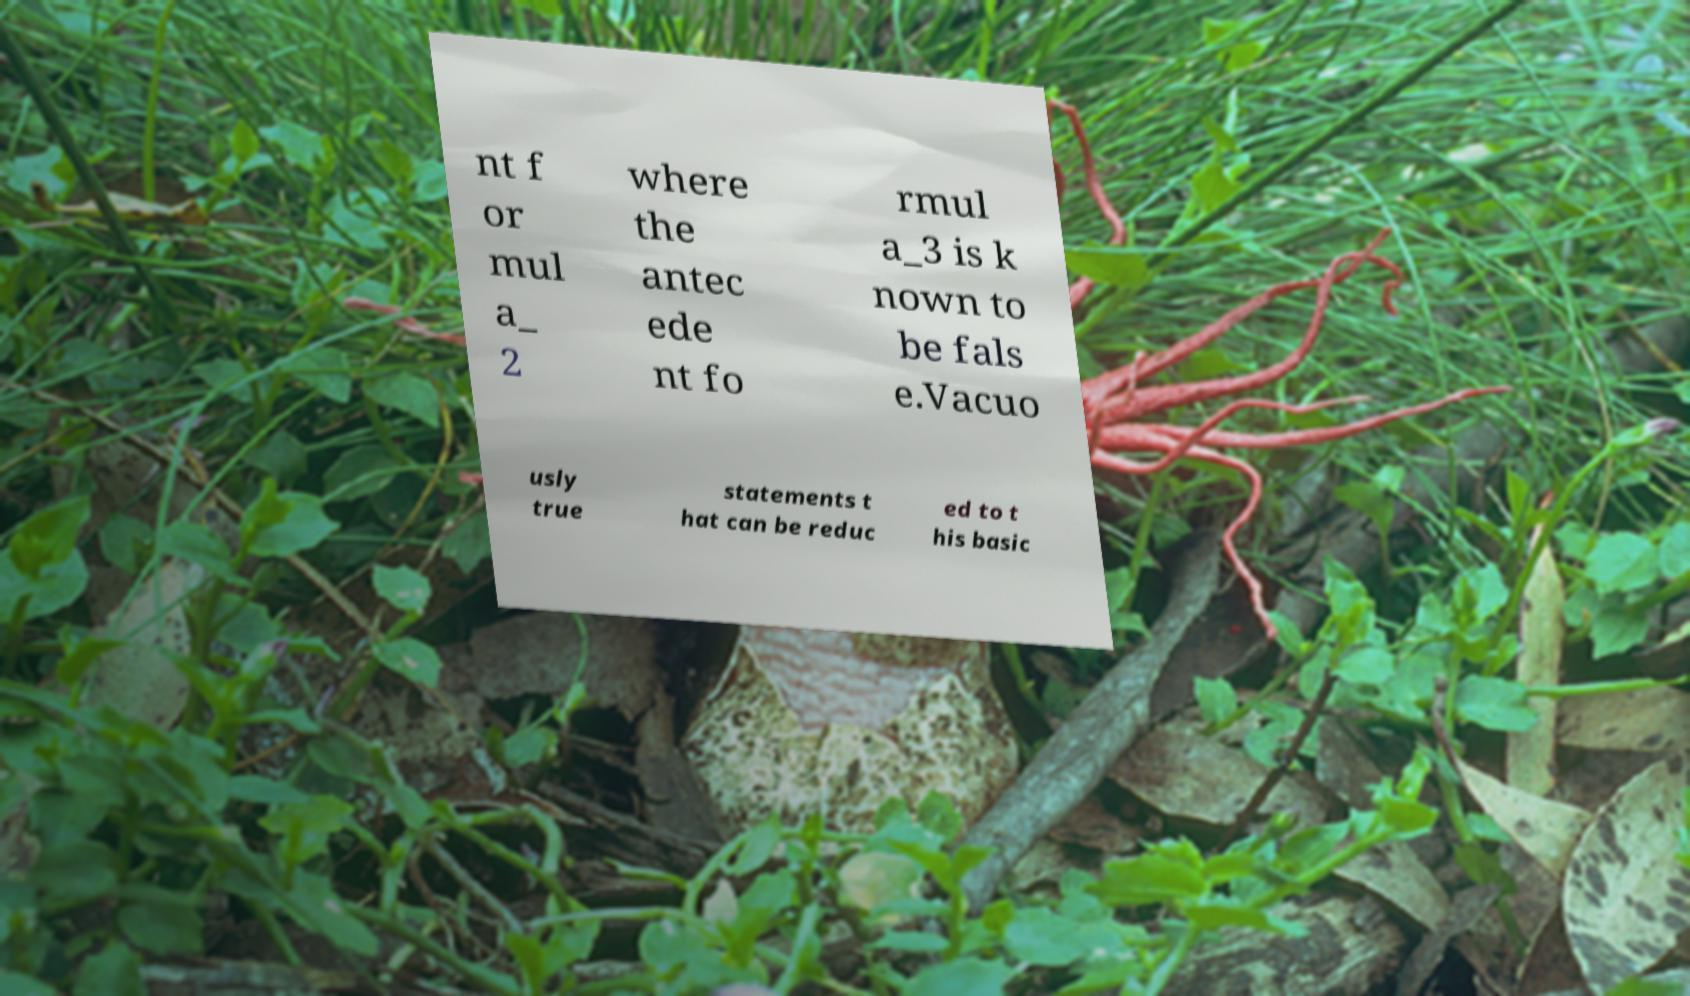There's text embedded in this image that I need extracted. Can you transcribe it verbatim? nt f or mul a_ 2 where the antec ede nt fo rmul a_3 is k nown to be fals e.Vacuo usly true statements t hat can be reduc ed to t his basic 